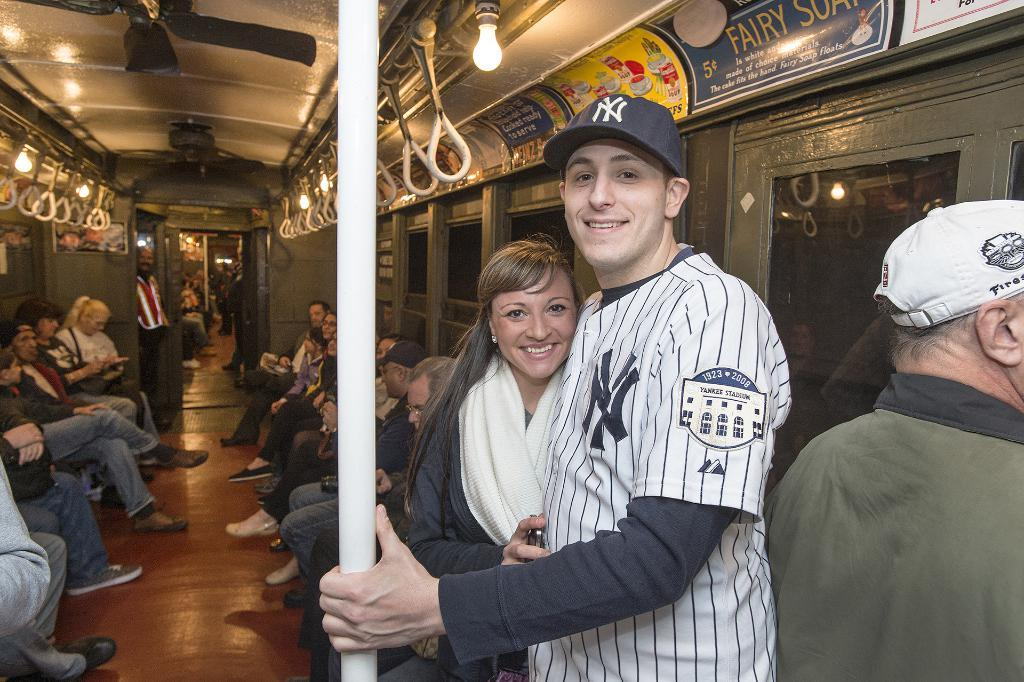Provide a one-sentence caption for the provided image. a NY logo that is on a baseball jersey. 